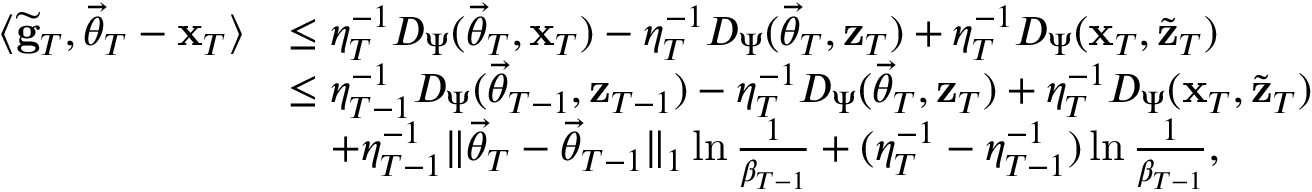<formula> <loc_0><loc_0><loc_500><loc_500>\begin{array} { r l } { \langle \widetilde { \mathbf g } _ { T } , \vec { \theta } _ { T } - \mathbf x _ { T } \rangle } & { \leq \eta _ { T } ^ { - 1 } D _ { \Psi } ( \vec { \theta } _ { T } , \mathbf x _ { T } ) - \eta _ { T } ^ { - 1 } D _ { \Psi } ( \vec { \theta } _ { T } , \mathbf z _ { T } ) + \eta _ { T } ^ { - 1 } D _ { \Psi } ( \mathbf x _ { T } , \widetilde { \mathbf z } _ { T } ) } \\ & { \leq \eta _ { T - 1 } ^ { - 1 } D _ { \Psi } ( \vec { \theta } _ { T - 1 } , \mathbf z _ { T - 1 } ) - \eta _ { T } ^ { - 1 } D _ { \Psi } ( \vec { \theta } _ { T } , \mathbf z _ { T } ) + \eta _ { T } ^ { - 1 } D _ { \Psi } ( \mathbf x _ { T } , \widetilde { \mathbf z } _ { T } ) } \\ & { \quad + \eta _ { T - 1 } ^ { - 1 } \| \vec { \theta } _ { T } - \vec { \theta } _ { T - 1 } \| _ { 1 } \ln \frac { 1 } \beta _ { T - 1 } } + ( \eta _ { T } ^ { - 1 } - \eta _ { T - 1 } ^ { - 1 } ) \ln \frac { 1 } \beta _ { T - 1 } } , } \end{array}</formula> 